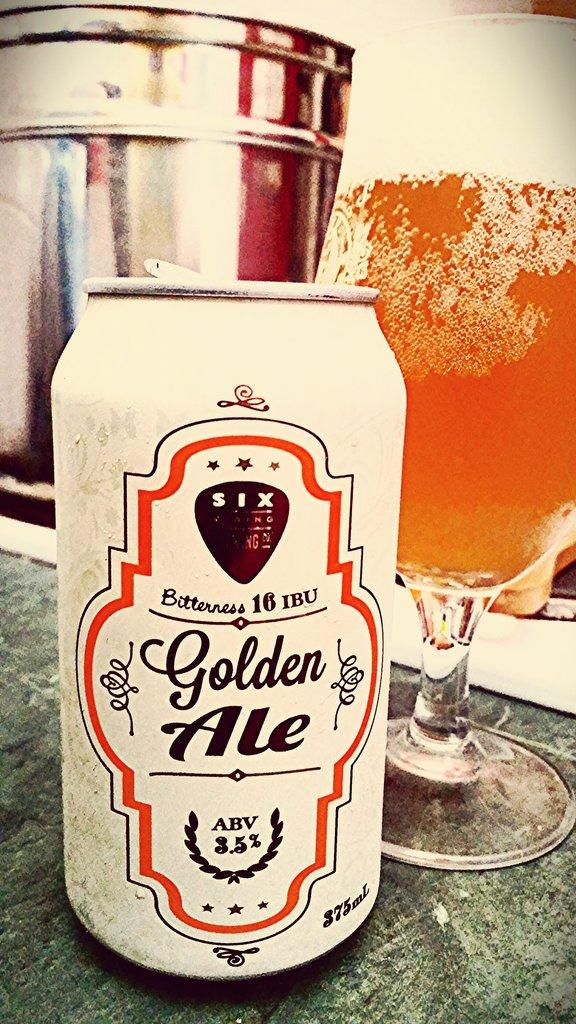Provide a one-sentence caption for the provided image. Bitterness 16 IBU Golden Ale positioned next to a beer glass with a perfect pour. 